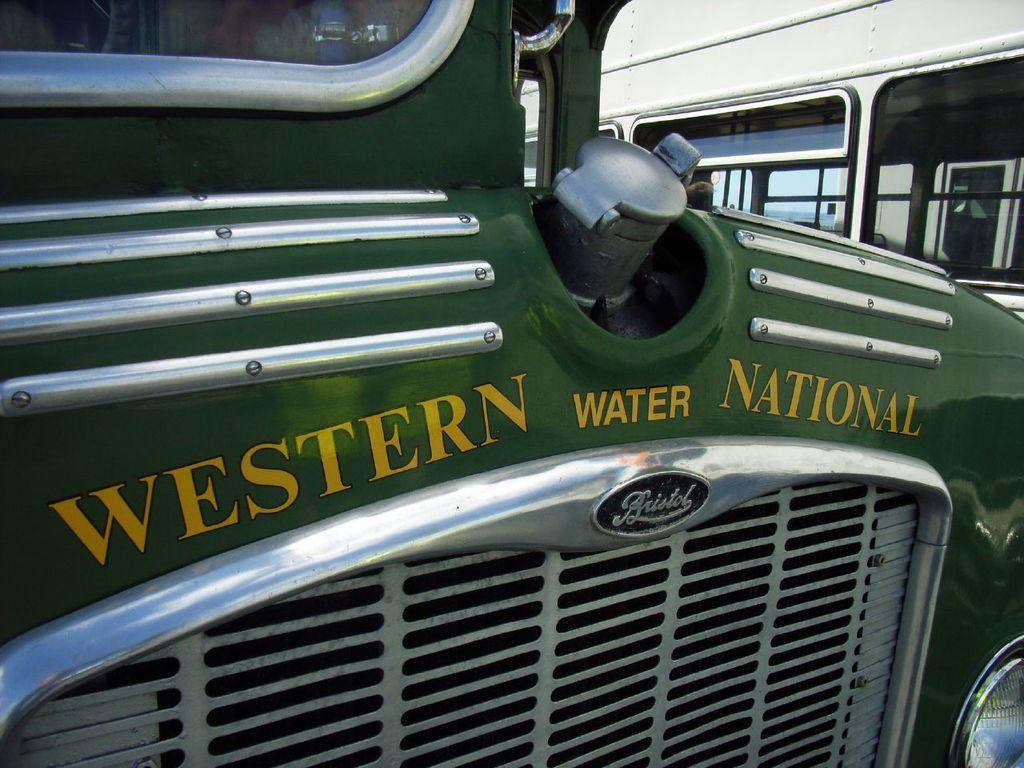What types of objects are present in the image? There are vehicles in the image. Can you describe the colors of the vehicles? One vehicle is green in color, and another vehicle is white in color. Are there any houses emitting smoke in the image? There is no mention of houses or smoke in the image; it only features vehicles in green and white colors. 